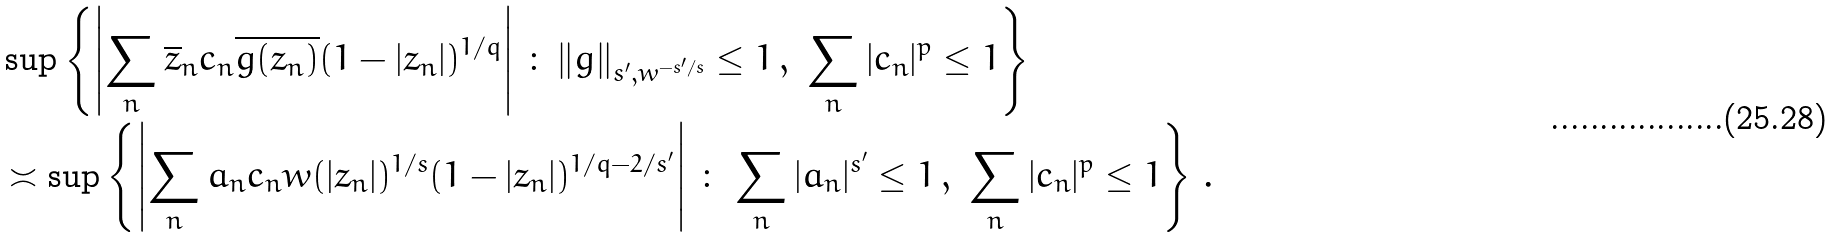Convert formula to latex. <formula><loc_0><loc_0><loc_500><loc_500>& \sup \left \{ \left | \sum _ { n } \overline { z } _ { n } c _ { n } \overline { g ( z _ { n } ) } ( 1 - | z _ { n } | ) ^ { 1 / q } \right | \, \colon \, \| g \| _ { s ^ { \prime } , w ^ { - s ^ { \prime } / s } } \leq 1 \, , \ \sum _ { n } | c _ { n } | ^ { p } \leq 1 \right \} \\ & \asymp \sup \left \{ \left | \sum _ { n } a _ { n } c _ { n } w ( | z _ { n } | ) ^ { 1 / s } ( 1 - | z _ { n } | ) ^ { 1 / q - 2 / s ^ { \prime } } \right | \, \colon \, \sum _ { n } | a _ { n } | ^ { s ^ { \prime } } \leq 1 \, , \ \sum _ { n } | c _ { n } | ^ { p } \leq 1 \right \} \, .</formula> 